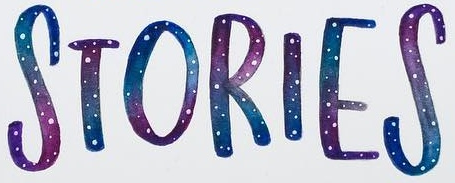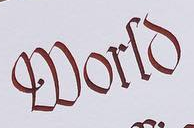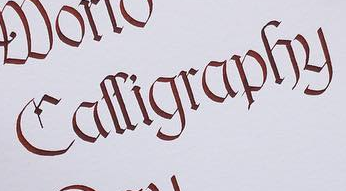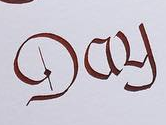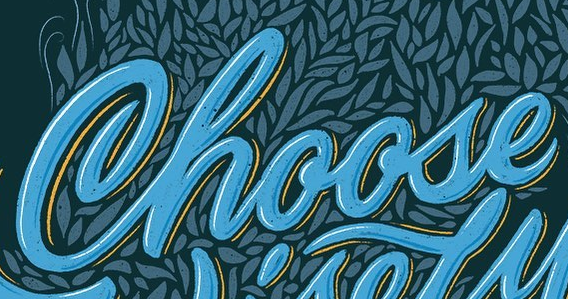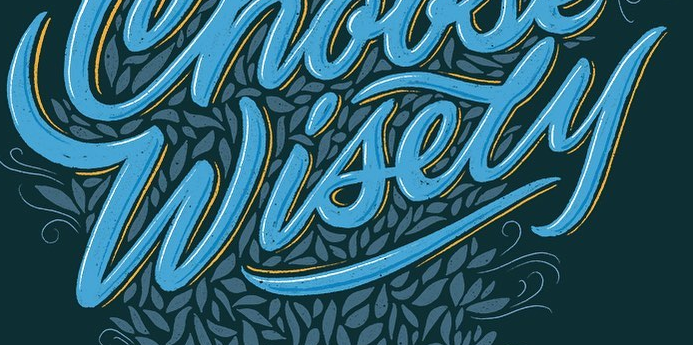What text appears in these images from left to right, separated by a semicolon? STORIES; World; Calligraphy; Day; Choose; Wisely 